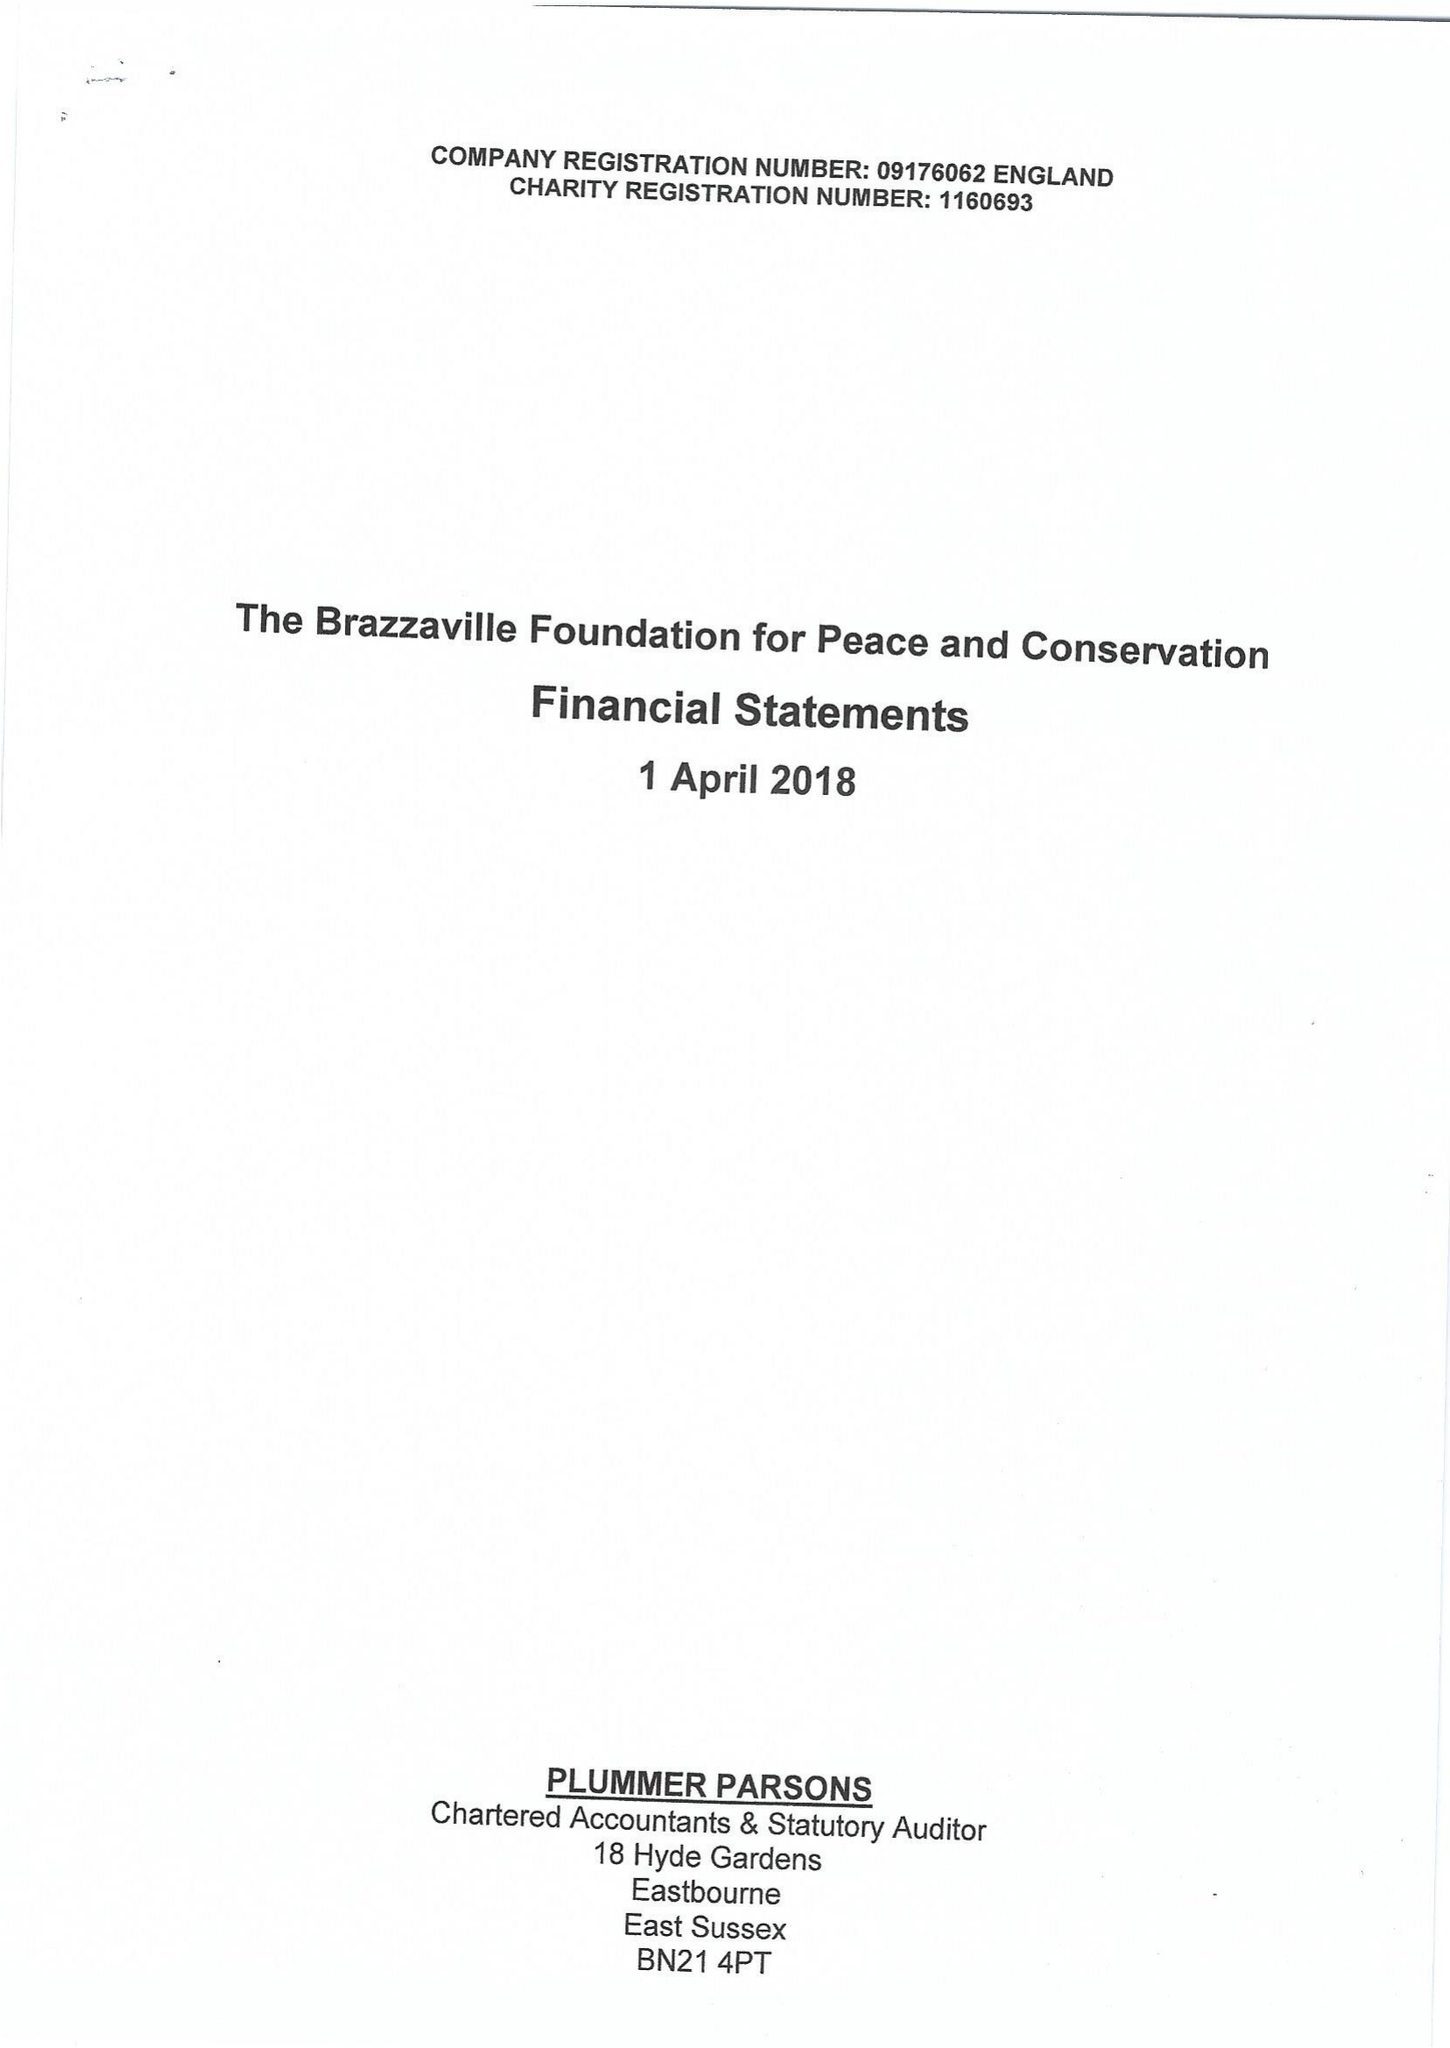What is the value for the income_annually_in_british_pounds?
Answer the question using a single word or phrase. 459169.00 